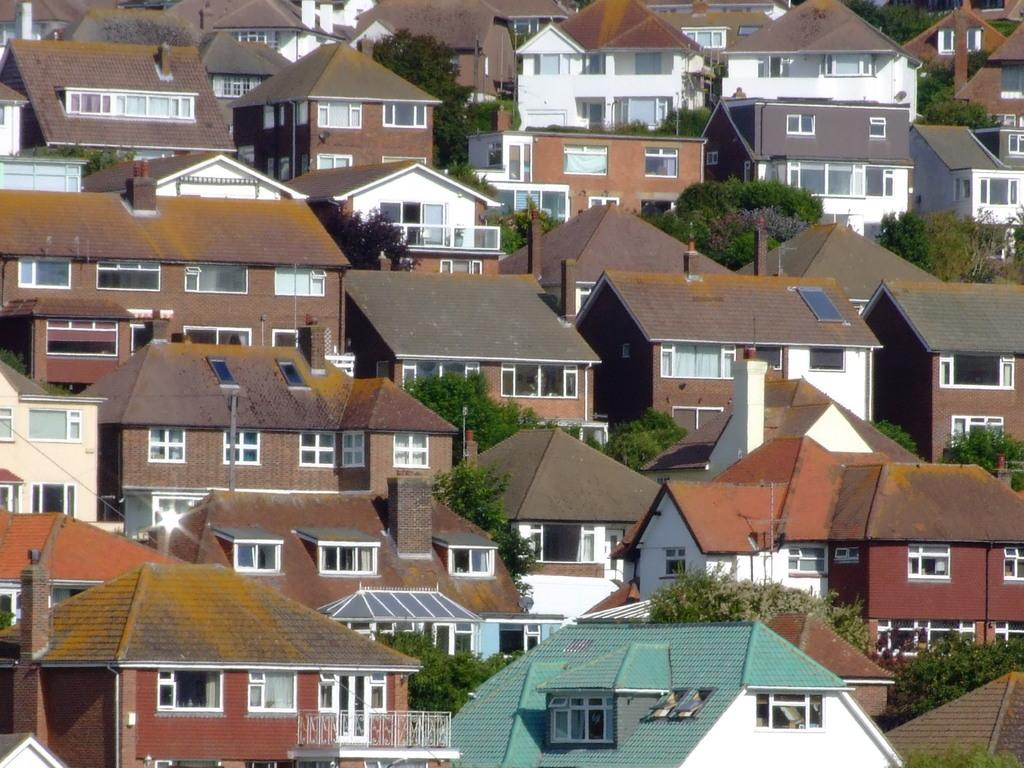What type of structures can be seen in the picture? There are buildings in the picture. What other elements are present in the picture besides the buildings? There are trees in the picture. What feature can be observed on the buildings? The buildings have windows. How many tables can be seen in the picture? There are no tables present in the image. 